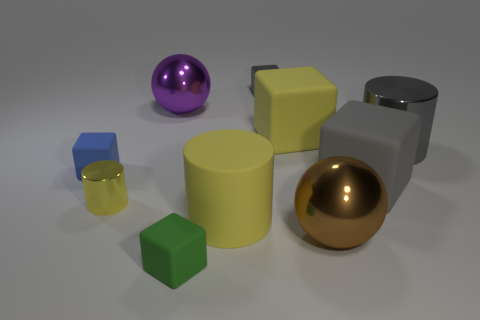Is there anything else of the same color as the small metallic block?
Offer a terse response. Yes. There is a gray thing that is the same shape as the yellow metallic object; what material is it?
Provide a succinct answer. Metal. What number of other things are there of the same size as the yellow metal cylinder?
Provide a succinct answer. 3. What is the material of the yellow block?
Give a very brief answer. Rubber. Is the number of tiny gray metallic cubes left of the tiny green block greater than the number of rubber objects?
Your answer should be compact. No. Are any small gray cylinders visible?
Your response must be concise. No. How many other things are the same shape as the small yellow thing?
Your answer should be very brief. 2. Is the color of the tiny block that is behind the big purple thing the same as the metallic cylinder in front of the blue rubber object?
Offer a terse response. No. There is a metal cylinder that is on the left side of the cube that is in front of the yellow rubber object left of the small gray metal cube; what is its size?
Your response must be concise. Small. What is the shape of the tiny object that is both left of the big purple metal thing and to the right of the small blue matte block?
Your answer should be very brief. Cylinder. 